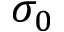<formula> <loc_0><loc_0><loc_500><loc_500>\sigma _ { 0 }</formula> 